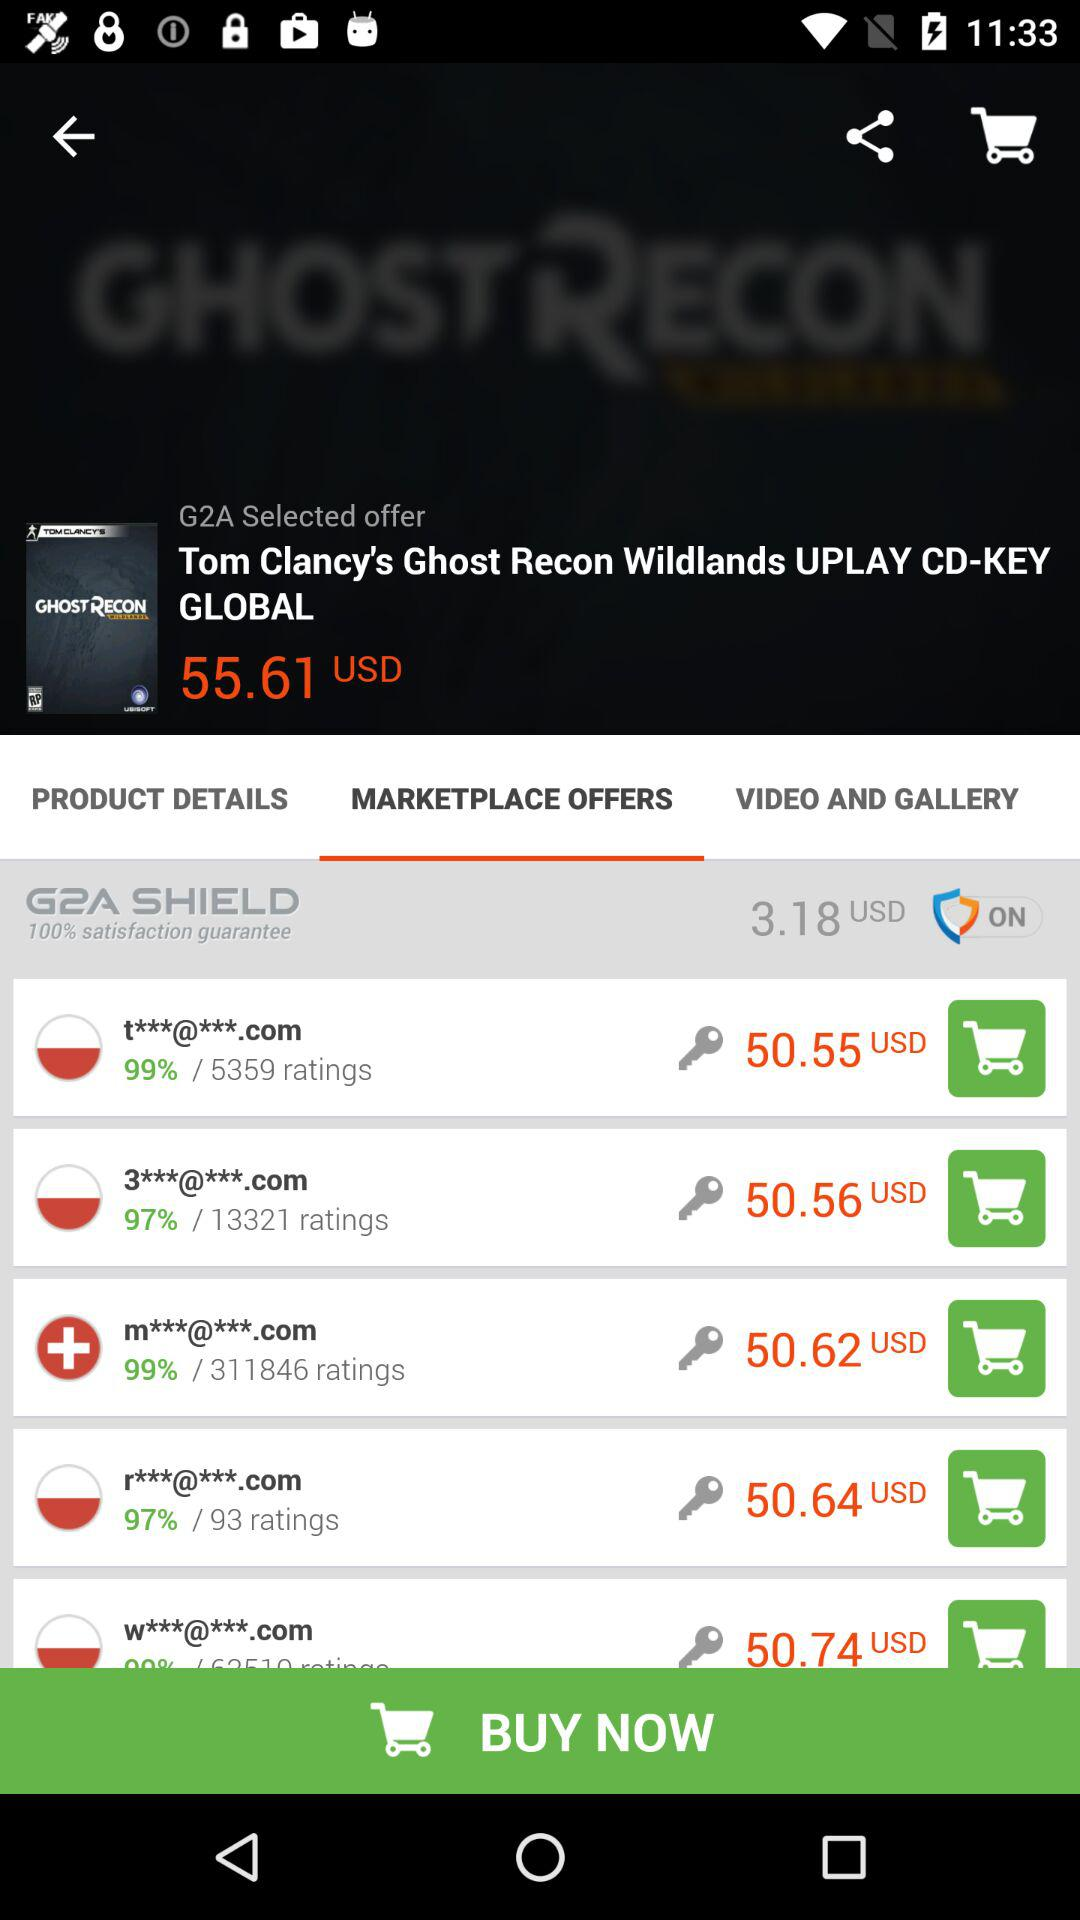Which tab has been selected? The tab that has been selected is "MARKETPLACE OFFERS". 